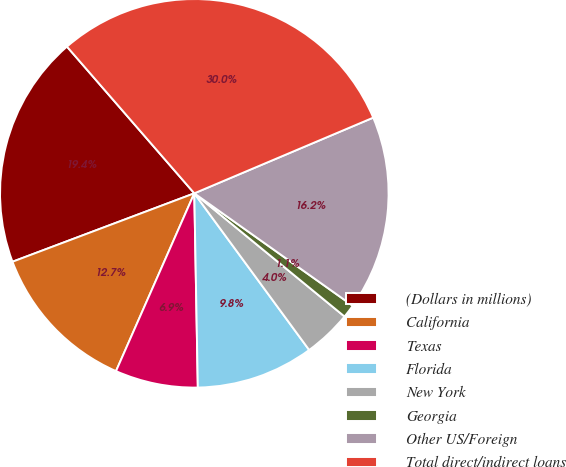Convert chart. <chart><loc_0><loc_0><loc_500><loc_500><pie_chart><fcel>(Dollars in millions)<fcel>California<fcel>Texas<fcel>Florida<fcel>New York<fcel>Georgia<fcel>Other US/Foreign<fcel>Total direct/indirect loans<nl><fcel>19.35%<fcel>12.67%<fcel>6.89%<fcel>9.78%<fcel>4.0%<fcel>1.11%<fcel>16.19%<fcel>30.01%<nl></chart> 